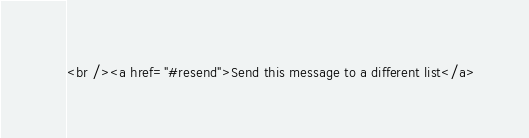<code> <loc_0><loc_0><loc_500><loc_500><_PHP_><br /><a href="#resend">Send this message to a different list</a>
</code> 